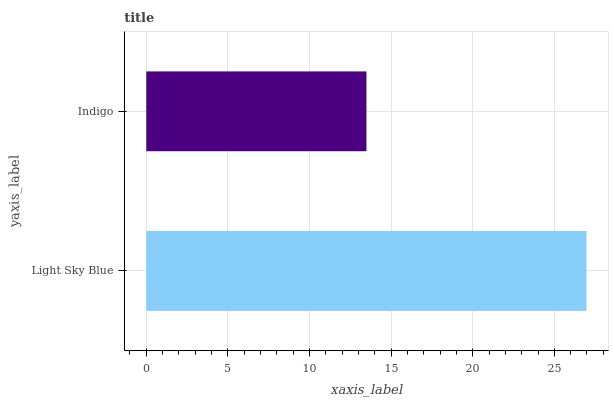Is Indigo the minimum?
Answer yes or no. Yes. Is Light Sky Blue the maximum?
Answer yes or no. Yes. Is Indigo the maximum?
Answer yes or no. No. Is Light Sky Blue greater than Indigo?
Answer yes or no. Yes. Is Indigo less than Light Sky Blue?
Answer yes or no. Yes. Is Indigo greater than Light Sky Blue?
Answer yes or no. No. Is Light Sky Blue less than Indigo?
Answer yes or no. No. Is Light Sky Blue the high median?
Answer yes or no. Yes. Is Indigo the low median?
Answer yes or no. Yes. Is Indigo the high median?
Answer yes or no. No. Is Light Sky Blue the low median?
Answer yes or no. No. 